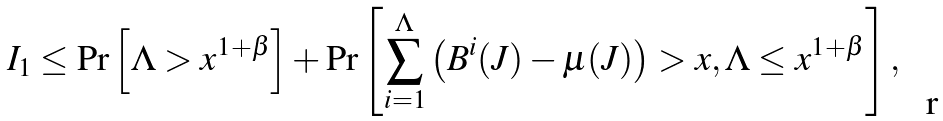Convert formula to latex. <formula><loc_0><loc_0><loc_500><loc_500>I _ { 1 } & \leq \Pr \left [ \Lambda > x ^ { 1 + \beta } \right ] + \Pr \left [ \sum _ { i = 1 } ^ { \Lambda } \left ( B ^ { i } ( J ) - \mu ( J ) \right ) > x , \Lambda \leq x ^ { 1 + \beta } \right ] ,</formula> 